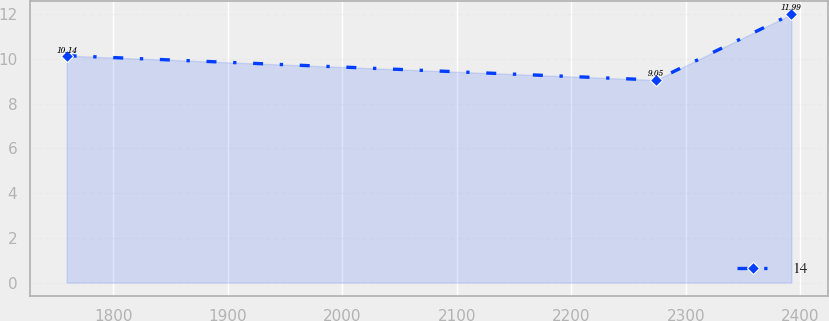Convert chart. <chart><loc_0><loc_0><loc_500><loc_500><line_chart><ecel><fcel>14<nl><fcel>1759.08<fcel>10.14<nl><fcel>2274.17<fcel>9.05<nl><fcel>2392.26<fcel>11.99<nl></chart> 